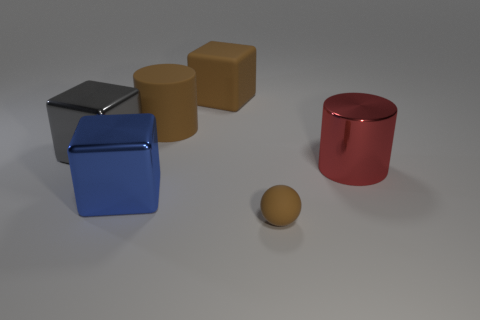Add 1 big red things. How many objects exist? 7 Subtract all cylinders. How many objects are left? 4 Add 3 big brown rubber cubes. How many big brown rubber cubes exist? 4 Subtract 0 cyan cubes. How many objects are left? 6 Subtract all small brown matte balls. Subtract all big gray metallic blocks. How many objects are left? 4 Add 2 shiny things. How many shiny things are left? 5 